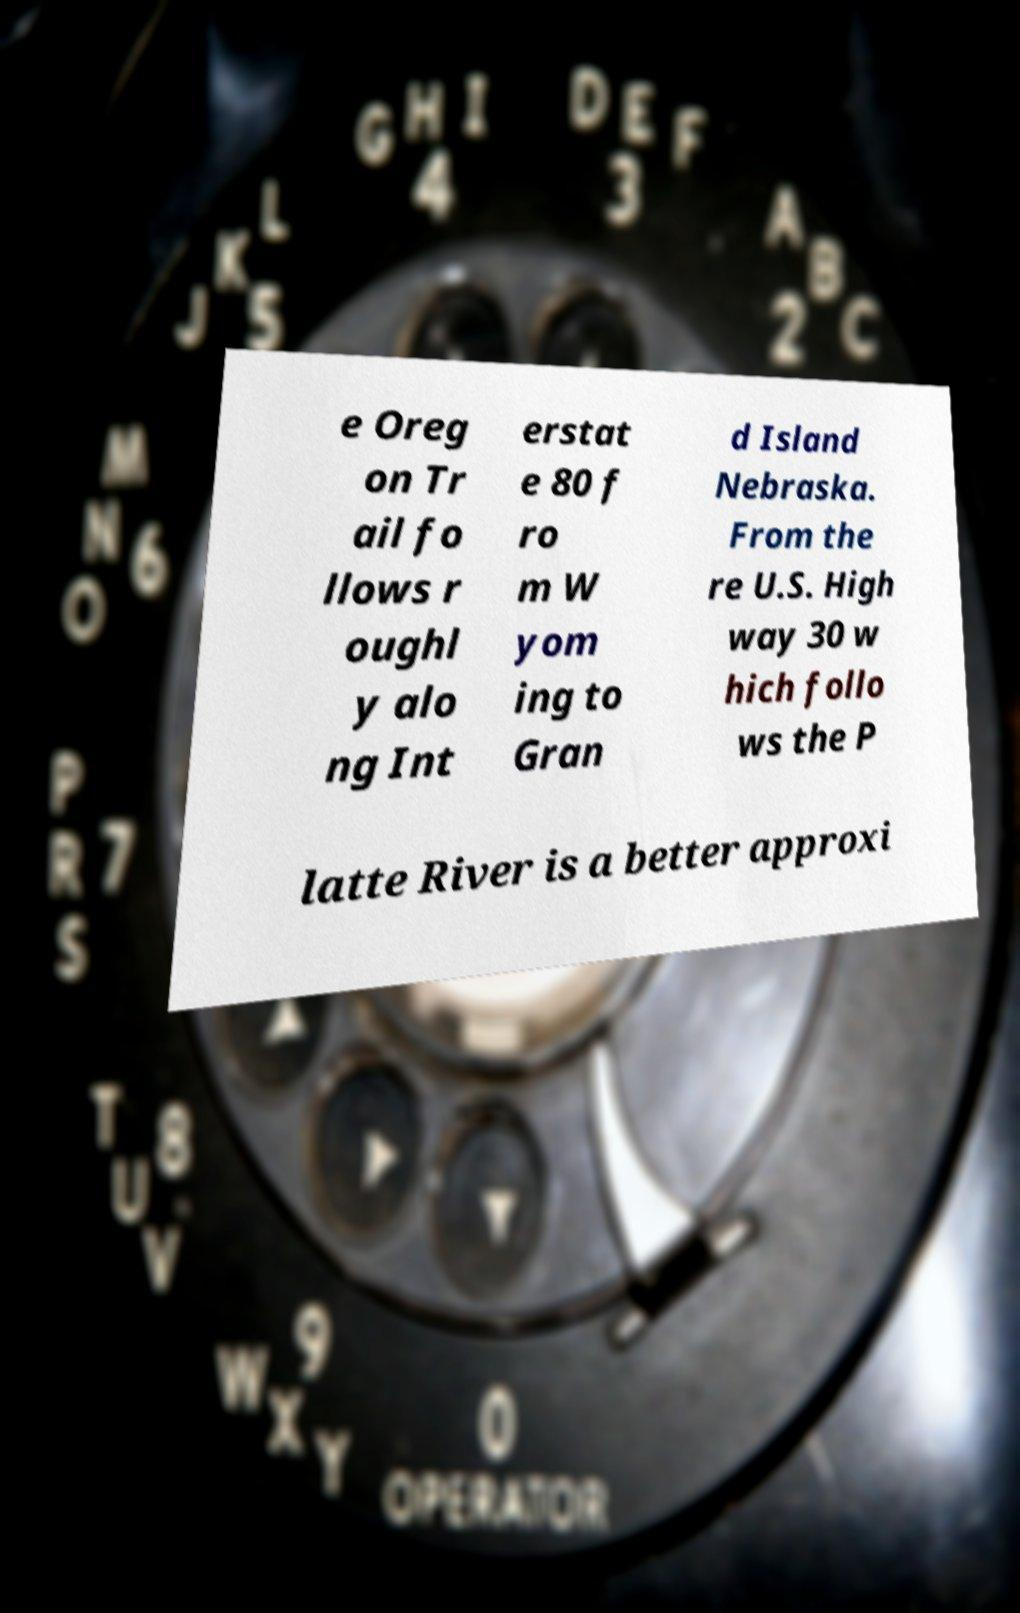There's text embedded in this image that I need extracted. Can you transcribe it verbatim? e Oreg on Tr ail fo llows r oughl y alo ng Int erstat e 80 f ro m W yom ing to Gran d Island Nebraska. From the re U.S. High way 30 w hich follo ws the P latte River is a better approxi 